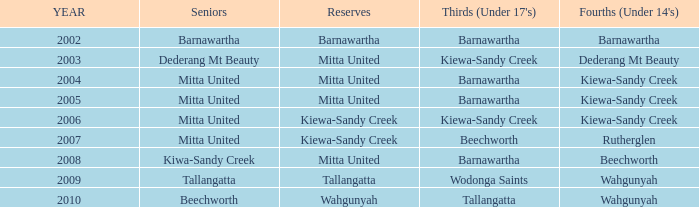Which seniors have a year before 2007, Fourths (Under 14's) of kiewa-sandy creek, and a Reserve of mitta united? Mitta United, Mitta United. Parse the full table. {'header': ['YEAR', 'Seniors', 'Reserves', "Thirds (Under 17's)", "Fourths (Under 14's)"], 'rows': [['2002', 'Barnawartha', 'Barnawartha', 'Barnawartha', 'Barnawartha'], ['2003', 'Dederang Mt Beauty', 'Mitta United', 'Kiewa-Sandy Creek', 'Dederang Mt Beauty'], ['2004', 'Mitta United', 'Mitta United', 'Barnawartha', 'Kiewa-Sandy Creek'], ['2005', 'Mitta United', 'Mitta United', 'Barnawartha', 'Kiewa-Sandy Creek'], ['2006', 'Mitta United', 'Kiewa-Sandy Creek', 'Kiewa-Sandy Creek', 'Kiewa-Sandy Creek'], ['2007', 'Mitta United', 'Kiewa-Sandy Creek', 'Beechworth', 'Rutherglen'], ['2008', 'Kiwa-Sandy Creek', 'Mitta United', 'Barnawartha', 'Beechworth'], ['2009', 'Tallangatta', 'Tallangatta', 'Wodonga Saints', 'Wahgunyah'], ['2010', 'Beechworth', 'Wahgunyah', 'Tallangatta', 'Wahgunyah']]} 